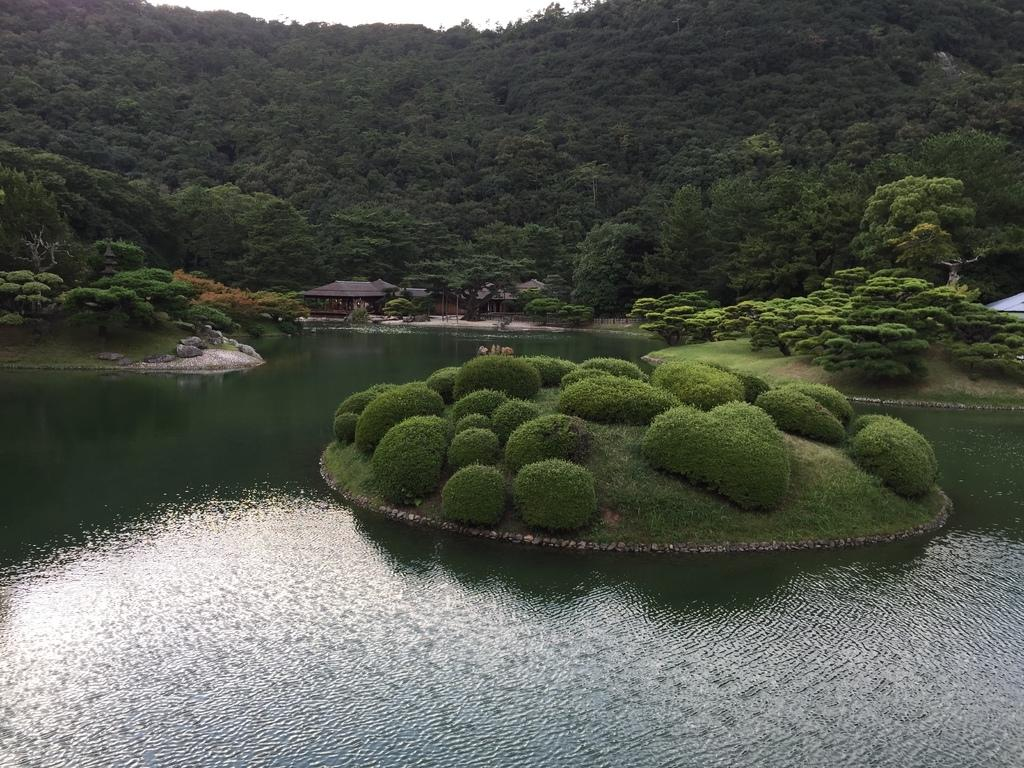What type of landscape is depicted in the image? The image features hills, trees, sheds, and hedges. Can you describe the vegetation in the image? There are trees and hedges in the image. What type of structures can be seen in the image? There are sheds in the image. What is at the bottom of the image? There is water at the bottom of the image. How many hens are perched on the lip of the water in the image? There are no hens or lips present in the image. 